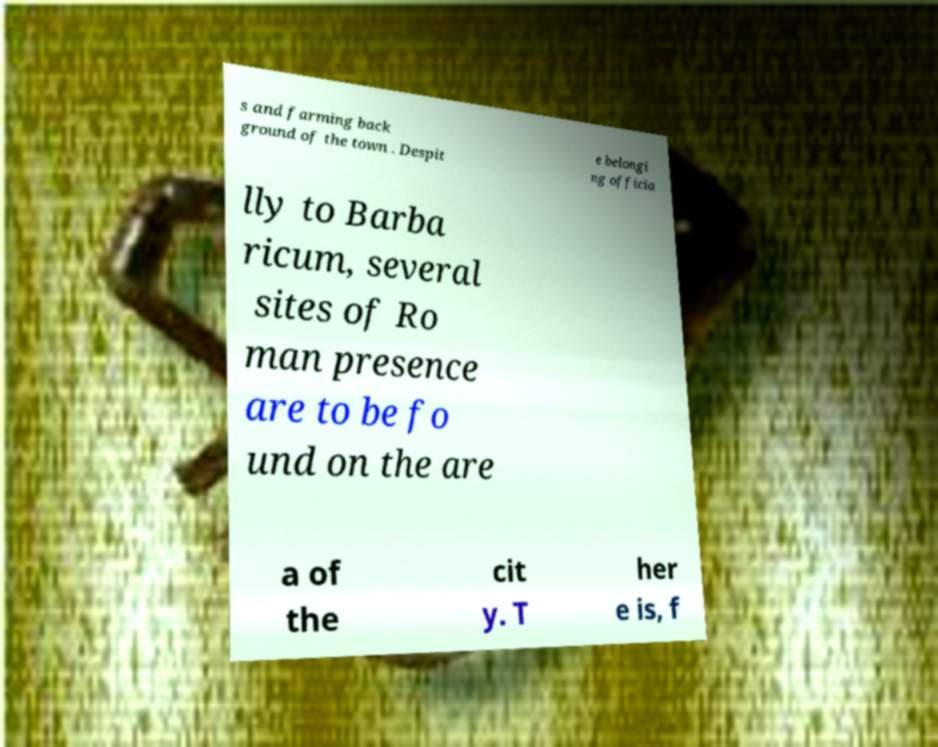Please read and relay the text visible in this image. What does it say? s and farming back ground of the town . Despit e belongi ng officia lly to Barba ricum, several sites of Ro man presence are to be fo und on the are a of the cit y. T her e is, f 